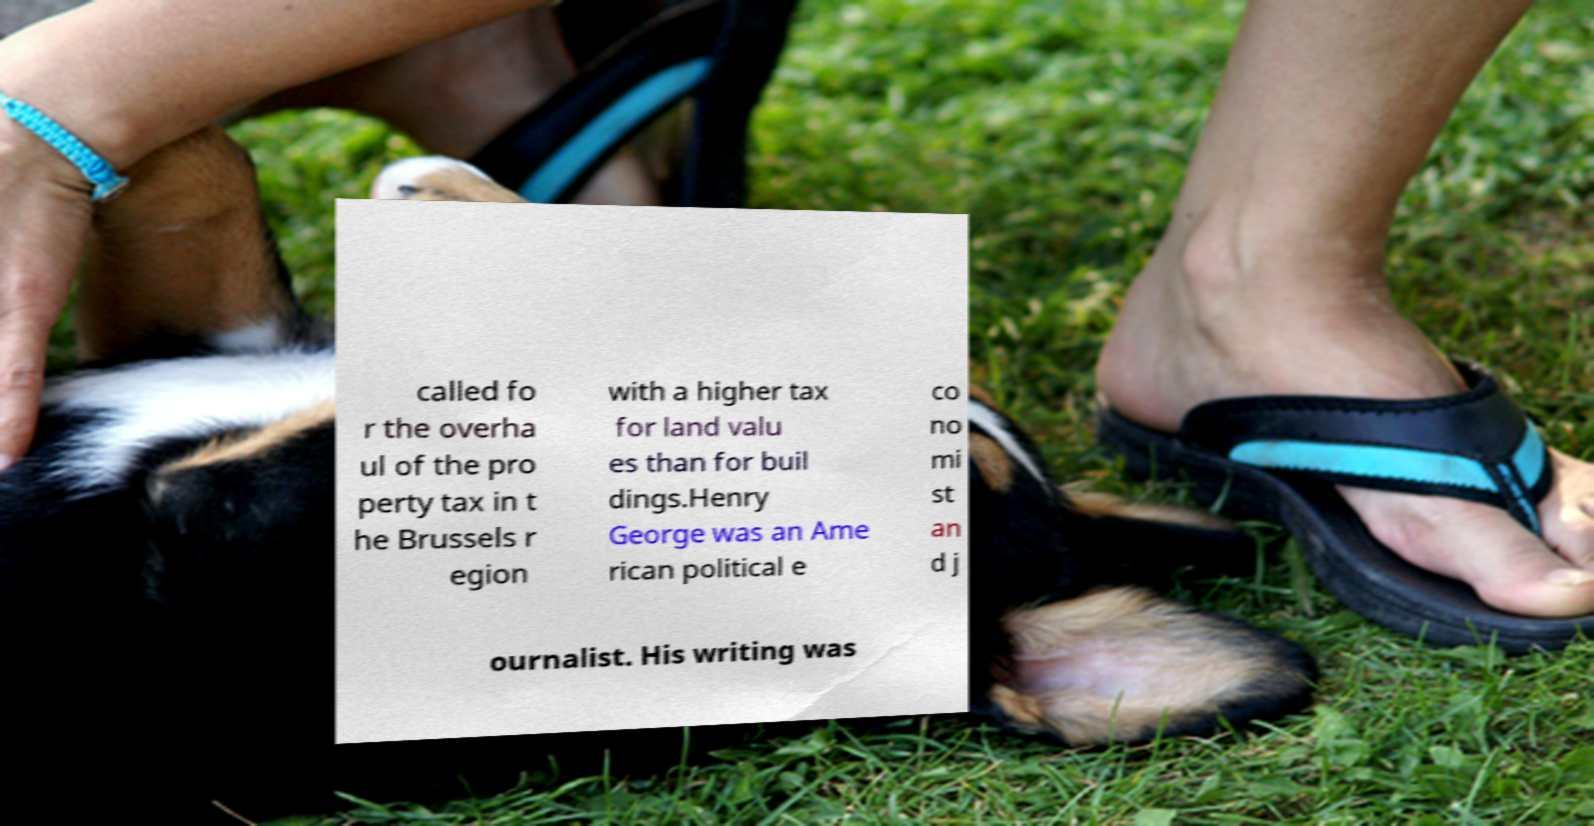For documentation purposes, I need the text within this image transcribed. Could you provide that? called fo r the overha ul of the pro perty tax in t he Brussels r egion with a higher tax for land valu es than for buil dings.Henry George was an Ame rican political e co no mi st an d j ournalist. His writing was 